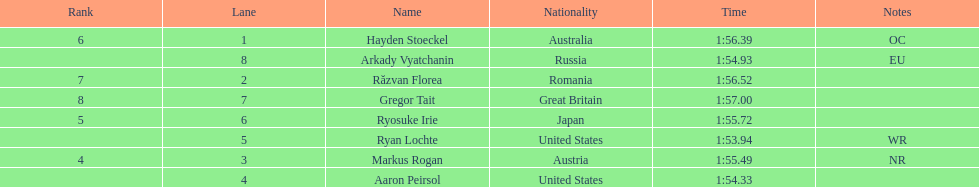Which country had the most medals in the competition? United States. 